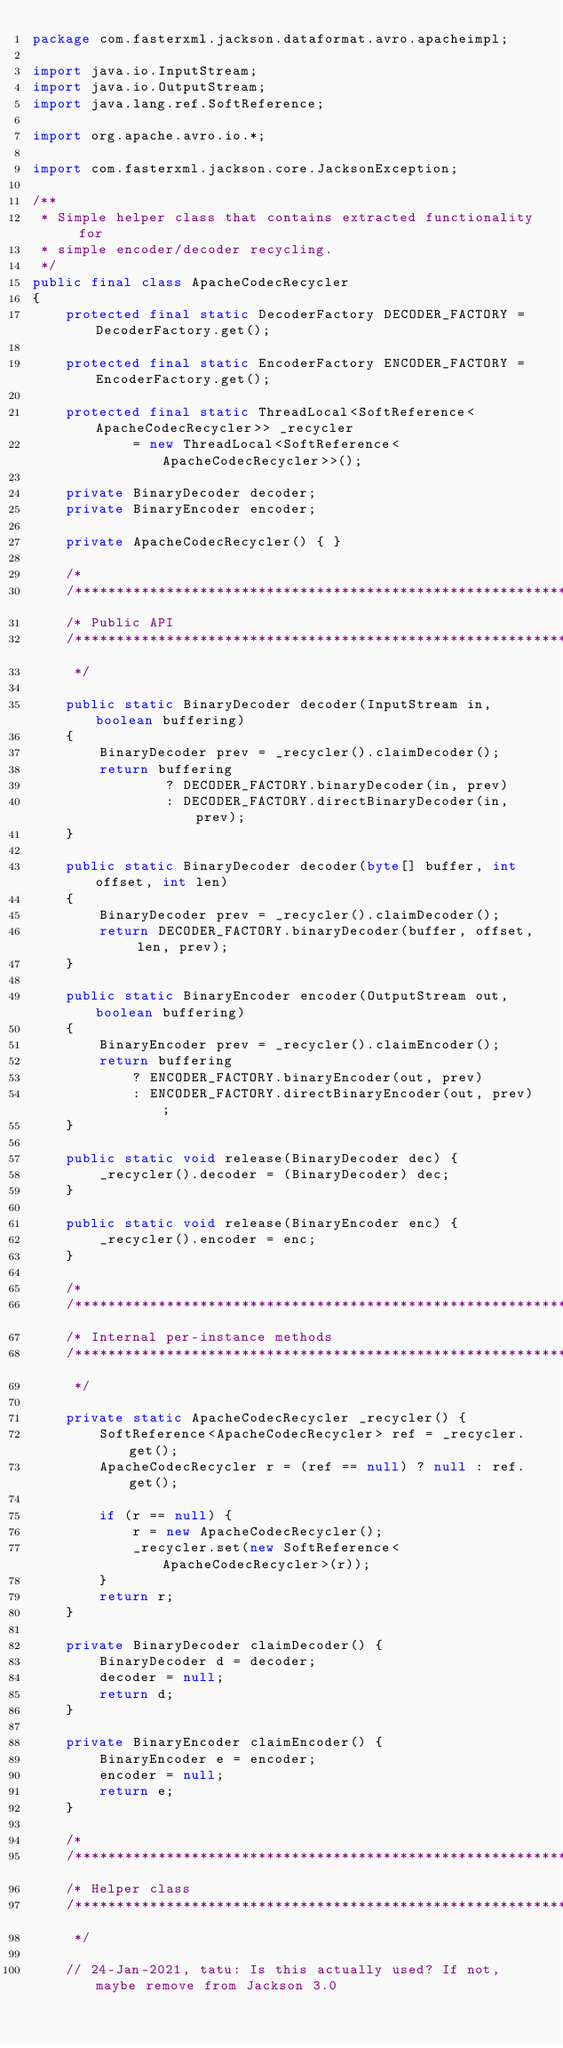Convert code to text. <code><loc_0><loc_0><loc_500><loc_500><_Java_>package com.fasterxml.jackson.dataformat.avro.apacheimpl;

import java.io.InputStream;
import java.io.OutputStream;
import java.lang.ref.SoftReference;

import org.apache.avro.io.*;

import com.fasterxml.jackson.core.JacksonException;

/**
 * Simple helper class that contains extracted functionality for
 * simple encoder/decoder recycling.
 */
public final class ApacheCodecRecycler
{
    protected final static DecoderFactory DECODER_FACTORY = DecoderFactory.get();

    protected final static EncoderFactory ENCODER_FACTORY = EncoderFactory.get();

    protected final static ThreadLocal<SoftReference<ApacheCodecRecycler>> _recycler
            = new ThreadLocal<SoftReference<ApacheCodecRecycler>>();

    private BinaryDecoder decoder;
    private BinaryEncoder encoder;

    private ApacheCodecRecycler() { }

    /*
    /**********************************************************************
    /* Public API
    /**********************************************************************
     */

    public static BinaryDecoder decoder(InputStream in, boolean buffering)
    {
        BinaryDecoder prev = _recycler().claimDecoder();
        return buffering
                ? DECODER_FACTORY.binaryDecoder(in, prev)
                : DECODER_FACTORY.directBinaryDecoder(in, prev);
    }

    public static BinaryDecoder decoder(byte[] buffer, int offset, int len)
    {
        BinaryDecoder prev = _recycler().claimDecoder();
        return DECODER_FACTORY.binaryDecoder(buffer, offset, len, prev);
    }

    public static BinaryEncoder encoder(OutputStream out, boolean buffering)
    {
        BinaryEncoder prev = _recycler().claimEncoder();
        return buffering
            ? ENCODER_FACTORY.binaryEncoder(out, prev)
            : ENCODER_FACTORY.directBinaryEncoder(out, prev);
    }

    public static void release(BinaryDecoder dec) {
        _recycler().decoder = (BinaryDecoder) dec;
    }

    public static void release(BinaryEncoder enc) {
        _recycler().encoder = enc;
    }

    /*
    /**********************************************************************
    /* Internal per-instance methods
    /**********************************************************************
     */
    
    private static ApacheCodecRecycler _recycler() {
        SoftReference<ApacheCodecRecycler> ref = _recycler.get();
        ApacheCodecRecycler r = (ref == null) ? null : ref.get();

        if (r == null) {
            r = new ApacheCodecRecycler();
            _recycler.set(new SoftReference<ApacheCodecRecycler>(r));
        }
        return r;
    }

    private BinaryDecoder claimDecoder() {
        BinaryDecoder d = decoder;
        decoder = null;
        return d;
    }

    private BinaryEncoder claimEncoder() {
        BinaryEncoder e = encoder;
        encoder = null;
        return e;
    }

    /*
    /**********************************************************************
    /* Helper class
    /**********************************************************************
     */

    // 24-Jan-2021, tatu: Is this actually used? If not, maybe remove from Jackson 3.0</code> 